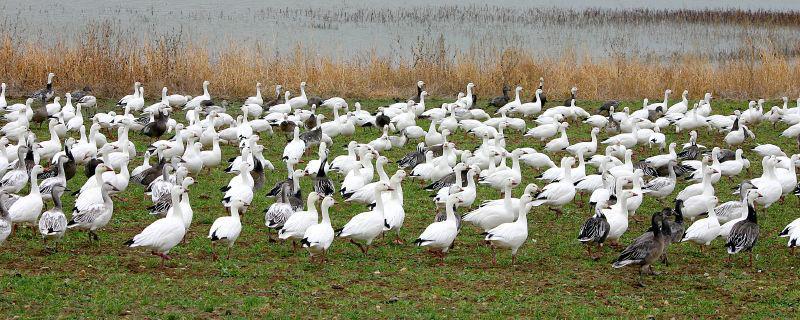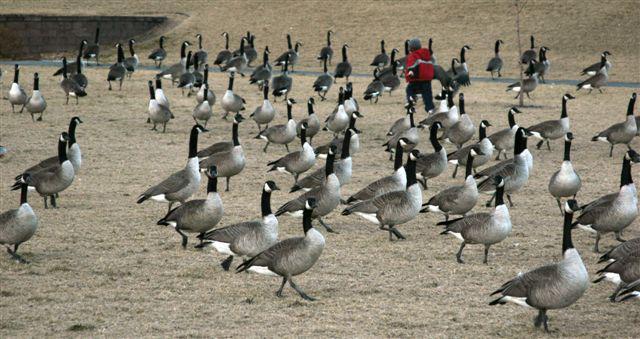The first image is the image on the left, the second image is the image on the right. Considering the images on both sides, is "In one image, white ducks and geese are congregated on a green grassy field." valid? Answer yes or no. Yes. The first image is the image on the left, the second image is the image on the right. Considering the images on both sides, is "The left image contains no more than 13 birds." valid? Answer yes or no. No. The first image is the image on the left, the second image is the image on the right. Evaluate the accuracy of this statement regarding the images: "There is water in the image on the left.". Is it true? Answer yes or no. Yes. 